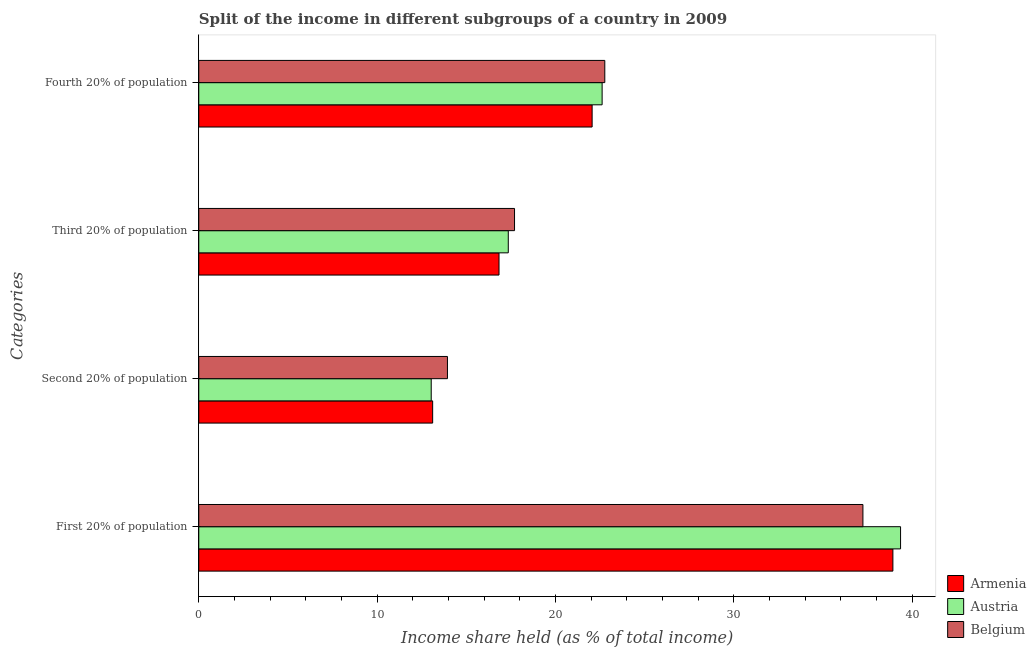How many groups of bars are there?
Make the answer very short. 4. Are the number of bars per tick equal to the number of legend labels?
Offer a terse response. Yes. Are the number of bars on each tick of the Y-axis equal?
Provide a succinct answer. Yes. How many bars are there on the 3rd tick from the top?
Offer a terse response. 3. What is the label of the 2nd group of bars from the top?
Make the answer very short. Third 20% of population. What is the share of the income held by second 20% of the population in Belgium?
Your response must be concise. 13.94. Across all countries, what is the maximum share of the income held by fourth 20% of the population?
Your answer should be very brief. 22.76. Across all countries, what is the minimum share of the income held by second 20% of the population?
Offer a terse response. 13.03. In which country was the share of the income held by fourth 20% of the population minimum?
Offer a terse response. Armenia. What is the total share of the income held by second 20% of the population in the graph?
Provide a short and direct response. 40.08. What is the difference between the share of the income held by fourth 20% of the population in Belgium and that in Armenia?
Make the answer very short. 0.71. What is the difference between the share of the income held by third 20% of the population in Belgium and the share of the income held by fourth 20% of the population in Armenia?
Keep it short and to the point. -4.35. What is the average share of the income held by second 20% of the population per country?
Offer a very short reply. 13.36. What is the difference between the share of the income held by third 20% of the population and share of the income held by fourth 20% of the population in Belgium?
Provide a short and direct response. -5.06. In how many countries, is the share of the income held by third 20% of the population greater than 24 %?
Your answer should be compact. 0. What is the ratio of the share of the income held by third 20% of the population in Belgium to that in Austria?
Give a very brief answer. 1.02. Is the share of the income held by fourth 20% of the population in Belgium less than that in Armenia?
Offer a very short reply. No. Is the difference between the share of the income held by first 20% of the population in Belgium and Austria greater than the difference between the share of the income held by fourth 20% of the population in Belgium and Austria?
Give a very brief answer. No. What is the difference between the highest and the second highest share of the income held by second 20% of the population?
Provide a short and direct response. 0.83. What is the difference between the highest and the lowest share of the income held by fourth 20% of the population?
Provide a short and direct response. 0.71. Is the sum of the share of the income held by first 20% of the population in Austria and Armenia greater than the maximum share of the income held by second 20% of the population across all countries?
Provide a short and direct response. Yes. What does the 1st bar from the bottom in Third 20% of population represents?
Your answer should be very brief. Armenia. How many bars are there?
Offer a terse response. 12. Are all the bars in the graph horizontal?
Offer a very short reply. Yes. How many legend labels are there?
Your response must be concise. 3. What is the title of the graph?
Make the answer very short. Split of the income in different subgroups of a country in 2009. Does "St. Lucia" appear as one of the legend labels in the graph?
Your response must be concise. No. What is the label or title of the X-axis?
Your answer should be compact. Income share held (as % of total income). What is the label or title of the Y-axis?
Provide a succinct answer. Categories. What is the Income share held (as % of total income) in Armenia in First 20% of population?
Make the answer very short. 38.91. What is the Income share held (as % of total income) in Austria in First 20% of population?
Offer a very short reply. 39.34. What is the Income share held (as % of total income) in Belgium in First 20% of population?
Make the answer very short. 37.23. What is the Income share held (as % of total income) in Armenia in Second 20% of population?
Your response must be concise. 13.11. What is the Income share held (as % of total income) of Austria in Second 20% of population?
Give a very brief answer. 13.03. What is the Income share held (as % of total income) of Belgium in Second 20% of population?
Offer a terse response. 13.94. What is the Income share held (as % of total income) in Armenia in Third 20% of population?
Make the answer very short. 16.83. What is the Income share held (as % of total income) in Austria in Third 20% of population?
Your answer should be very brief. 17.35. What is the Income share held (as % of total income) of Belgium in Third 20% of population?
Keep it short and to the point. 17.7. What is the Income share held (as % of total income) of Armenia in Fourth 20% of population?
Provide a succinct answer. 22.05. What is the Income share held (as % of total income) of Austria in Fourth 20% of population?
Ensure brevity in your answer.  22.61. What is the Income share held (as % of total income) of Belgium in Fourth 20% of population?
Your answer should be compact. 22.76. Across all Categories, what is the maximum Income share held (as % of total income) of Armenia?
Make the answer very short. 38.91. Across all Categories, what is the maximum Income share held (as % of total income) of Austria?
Your answer should be compact. 39.34. Across all Categories, what is the maximum Income share held (as % of total income) in Belgium?
Provide a succinct answer. 37.23. Across all Categories, what is the minimum Income share held (as % of total income) in Armenia?
Give a very brief answer. 13.11. Across all Categories, what is the minimum Income share held (as % of total income) of Austria?
Your answer should be very brief. 13.03. Across all Categories, what is the minimum Income share held (as % of total income) in Belgium?
Make the answer very short. 13.94. What is the total Income share held (as % of total income) of Armenia in the graph?
Keep it short and to the point. 90.9. What is the total Income share held (as % of total income) of Austria in the graph?
Give a very brief answer. 92.33. What is the total Income share held (as % of total income) in Belgium in the graph?
Ensure brevity in your answer.  91.63. What is the difference between the Income share held (as % of total income) of Armenia in First 20% of population and that in Second 20% of population?
Offer a terse response. 25.8. What is the difference between the Income share held (as % of total income) in Austria in First 20% of population and that in Second 20% of population?
Your response must be concise. 26.31. What is the difference between the Income share held (as % of total income) in Belgium in First 20% of population and that in Second 20% of population?
Offer a very short reply. 23.29. What is the difference between the Income share held (as % of total income) of Armenia in First 20% of population and that in Third 20% of population?
Keep it short and to the point. 22.08. What is the difference between the Income share held (as % of total income) in Austria in First 20% of population and that in Third 20% of population?
Ensure brevity in your answer.  21.99. What is the difference between the Income share held (as % of total income) in Belgium in First 20% of population and that in Third 20% of population?
Make the answer very short. 19.53. What is the difference between the Income share held (as % of total income) of Armenia in First 20% of population and that in Fourth 20% of population?
Your answer should be very brief. 16.86. What is the difference between the Income share held (as % of total income) in Austria in First 20% of population and that in Fourth 20% of population?
Keep it short and to the point. 16.73. What is the difference between the Income share held (as % of total income) of Belgium in First 20% of population and that in Fourth 20% of population?
Offer a very short reply. 14.47. What is the difference between the Income share held (as % of total income) in Armenia in Second 20% of population and that in Third 20% of population?
Give a very brief answer. -3.72. What is the difference between the Income share held (as % of total income) in Austria in Second 20% of population and that in Third 20% of population?
Your answer should be compact. -4.32. What is the difference between the Income share held (as % of total income) of Belgium in Second 20% of population and that in Third 20% of population?
Make the answer very short. -3.76. What is the difference between the Income share held (as % of total income) in Armenia in Second 20% of population and that in Fourth 20% of population?
Offer a terse response. -8.94. What is the difference between the Income share held (as % of total income) in Austria in Second 20% of population and that in Fourth 20% of population?
Provide a succinct answer. -9.58. What is the difference between the Income share held (as % of total income) of Belgium in Second 20% of population and that in Fourth 20% of population?
Keep it short and to the point. -8.82. What is the difference between the Income share held (as % of total income) in Armenia in Third 20% of population and that in Fourth 20% of population?
Give a very brief answer. -5.22. What is the difference between the Income share held (as % of total income) in Austria in Third 20% of population and that in Fourth 20% of population?
Offer a terse response. -5.26. What is the difference between the Income share held (as % of total income) in Belgium in Third 20% of population and that in Fourth 20% of population?
Offer a terse response. -5.06. What is the difference between the Income share held (as % of total income) of Armenia in First 20% of population and the Income share held (as % of total income) of Austria in Second 20% of population?
Keep it short and to the point. 25.88. What is the difference between the Income share held (as % of total income) of Armenia in First 20% of population and the Income share held (as % of total income) of Belgium in Second 20% of population?
Give a very brief answer. 24.97. What is the difference between the Income share held (as % of total income) in Austria in First 20% of population and the Income share held (as % of total income) in Belgium in Second 20% of population?
Provide a succinct answer. 25.4. What is the difference between the Income share held (as % of total income) of Armenia in First 20% of population and the Income share held (as % of total income) of Austria in Third 20% of population?
Offer a terse response. 21.56. What is the difference between the Income share held (as % of total income) of Armenia in First 20% of population and the Income share held (as % of total income) of Belgium in Third 20% of population?
Your response must be concise. 21.21. What is the difference between the Income share held (as % of total income) in Austria in First 20% of population and the Income share held (as % of total income) in Belgium in Third 20% of population?
Ensure brevity in your answer.  21.64. What is the difference between the Income share held (as % of total income) of Armenia in First 20% of population and the Income share held (as % of total income) of Austria in Fourth 20% of population?
Make the answer very short. 16.3. What is the difference between the Income share held (as % of total income) of Armenia in First 20% of population and the Income share held (as % of total income) of Belgium in Fourth 20% of population?
Offer a very short reply. 16.15. What is the difference between the Income share held (as % of total income) of Austria in First 20% of population and the Income share held (as % of total income) of Belgium in Fourth 20% of population?
Your response must be concise. 16.58. What is the difference between the Income share held (as % of total income) of Armenia in Second 20% of population and the Income share held (as % of total income) of Austria in Third 20% of population?
Make the answer very short. -4.24. What is the difference between the Income share held (as % of total income) of Armenia in Second 20% of population and the Income share held (as % of total income) of Belgium in Third 20% of population?
Offer a very short reply. -4.59. What is the difference between the Income share held (as % of total income) in Austria in Second 20% of population and the Income share held (as % of total income) in Belgium in Third 20% of population?
Offer a terse response. -4.67. What is the difference between the Income share held (as % of total income) of Armenia in Second 20% of population and the Income share held (as % of total income) of Belgium in Fourth 20% of population?
Your answer should be compact. -9.65. What is the difference between the Income share held (as % of total income) in Austria in Second 20% of population and the Income share held (as % of total income) in Belgium in Fourth 20% of population?
Your answer should be compact. -9.73. What is the difference between the Income share held (as % of total income) of Armenia in Third 20% of population and the Income share held (as % of total income) of Austria in Fourth 20% of population?
Ensure brevity in your answer.  -5.78. What is the difference between the Income share held (as % of total income) of Armenia in Third 20% of population and the Income share held (as % of total income) of Belgium in Fourth 20% of population?
Provide a short and direct response. -5.93. What is the difference between the Income share held (as % of total income) of Austria in Third 20% of population and the Income share held (as % of total income) of Belgium in Fourth 20% of population?
Offer a very short reply. -5.41. What is the average Income share held (as % of total income) in Armenia per Categories?
Make the answer very short. 22.73. What is the average Income share held (as % of total income) in Austria per Categories?
Provide a short and direct response. 23.08. What is the average Income share held (as % of total income) of Belgium per Categories?
Keep it short and to the point. 22.91. What is the difference between the Income share held (as % of total income) in Armenia and Income share held (as % of total income) in Austria in First 20% of population?
Your answer should be very brief. -0.43. What is the difference between the Income share held (as % of total income) in Armenia and Income share held (as % of total income) in Belgium in First 20% of population?
Offer a terse response. 1.68. What is the difference between the Income share held (as % of total income) of Austria and Income share held (as % of total income) of Belgium in First 20% of population?
Offer a terse response. 2.11. What is the difference between the Income share held (as % of total income) in Armenia and Income share held (as % of total income) in Belgium in Second 20% of population?
Keep it short and to the point. -0.83. What is the difference between the Income share held (as % of total income) of Austria and Income share held (as % of total income) of Belgium in Second 20% of population?
Give a very brief answer. -0.91. What is the difference between the Income share held (as % of total income) in Armenia and Income share held (as % of total income) in Austria in Third 20% of population?
Offer a terse response. -0.52. What is the difference between the Income share held (as % of total income) in Armenia and Income share held (as % of total income) in Belgium in Third 20% of population?
Your answer should be very brief. -0.87. What is the difference between the Income share held (as % of total income) in Austria and Income share held (as % of total income) in Belgium in Third 20% of population?
Ensure brevity in your answer.  -0.35. What is the difference between the Income share held (as % of total income) of Armenia and Income share held (as % of total income) of Austria in Fourth 20% of population?
Keep it short and to the point. -0.56. What is the difference between the Income share held (as % of total income) of Armenia and Income share held (as % of total income) of Belgium in Fourth 20% of population?
Make the answer very short. -0.71. What is the difference between the Income share held (as % of total income) of Austria and Income share held (as % of total income) of Belgium in Fourth 20% of population?
Provide a succinct answer. -0.15. What is the ratio of the Income share held (as % of total income) of Armenia in First 20% of population to that in Second 20% of population?
Ensure brevity in your answer.  2.97. What is the ratio of the Income share held (as % of total income) in Austria in First 20% of population to that in Second 20% of population?
Keep it short and to the point. 3.02. What is the ratio of the Income share held (as % of total income) of Belgium in First 20% of population to that in Second 20% of population?
Keep it short and to the point. 2.67. What is the ratio of the Income share held (as % of total income) in Armenia in First 20% of population to that in Third 20% of population?
Offer a very short reply. 2.31. What is the ratio of the Income share held (as % of total income) of Austria in First 20% of population to that in Third 20% of population?
Keep it short and to the point. 2.27. What is the ratio of the Income share held (as % of total income) in Belgium in First 20% of population to that in Third 20% of population?
Provide a succinct answer. 2.1. What is the ratio of the Income share held (as % of total income) of Armenia in First 20% of population to that in Fourth 20% of population?
Provide a short and direct response. 1.76. What is the ratio of the Income share held (as % of total income) in Austria in First 20% of population to that in Fourth 20% of population?
Give a very brief answer. 1.74. What is the ratio of the Income share held (as % of total income) of Belgium in First 20% of population to that in Fourth 20% of population?
Offer a terse response. 1.64. What is the ratio of the Income share held (as % of total income) of Armenia in Second 20% of population to that in Third 20% of population?
Your answer should be very brief. 0.78. What is the ratio of the Income share held (as % of total income) in Austria in Second 20% of population to that in Third 20% of population?
Your answer should be very brief. 0.75. What is the ratio of the Income share held (as % of total income) in Belgium in Second 20% of population to that in Third 20% of population?
Your answer should be very brief. 0.79. What is the ratio of the Income share held (as % of total income) in Armenia in Second 20% of population to that in Fourth 20% of population?
Make the answer very short. 0.59. What is the ratio of the Income share held (as % of total income) of Austria in Second 20% of population to that in Fourth 20% of population?
Offer a terse response. 0.58. What is the ratio of the Income share held (as % of total income) of Belgium in Second 20% of population to that in Fourth 20% of population?
Make the answer very short. 0.61. What is the ratio of the Income share held (as % of total income) of Armenia in Third 20% of population to that in Fourth 20% of population?
Keep it short and to the point. 0.76. What is the ratio of the Income share held (as % of total income) in Austria in Third 20% of population to that in Fourth 20% of population?
Offer a very short reply. 0.77. What is the ratio of the Income share held (as % of total income) in Belgium in Third 20% of population to that in Fourth 20% of population?
Your answer should be very brief. 0.78. What is the difference between the highest and the second highest Income share held (as % of total income) in Armenia?
Offer a very short reply. 16.86. What is the difference between the highest and the second highest Income share held (as % of total income) of Austria?
Your answer should be very brief. 16.73. What is the difference between the highest and the second highest Income share held (as % of total income) of Belgium?
Make the answer very short. 14.47. What is the difference between the highest and the lowest Income share held (as % of total income) in Armenia?
Keep it short and to the point. 25.8. What is the difference between the highest and the lowest Income share held (as % of total income) in Austria?
Provide a short and direct response. 26.31. What is the difference between the highest and the lowest Income share held (as % of total income) in Belgium?
Provide a short and direct response. 23.29. 